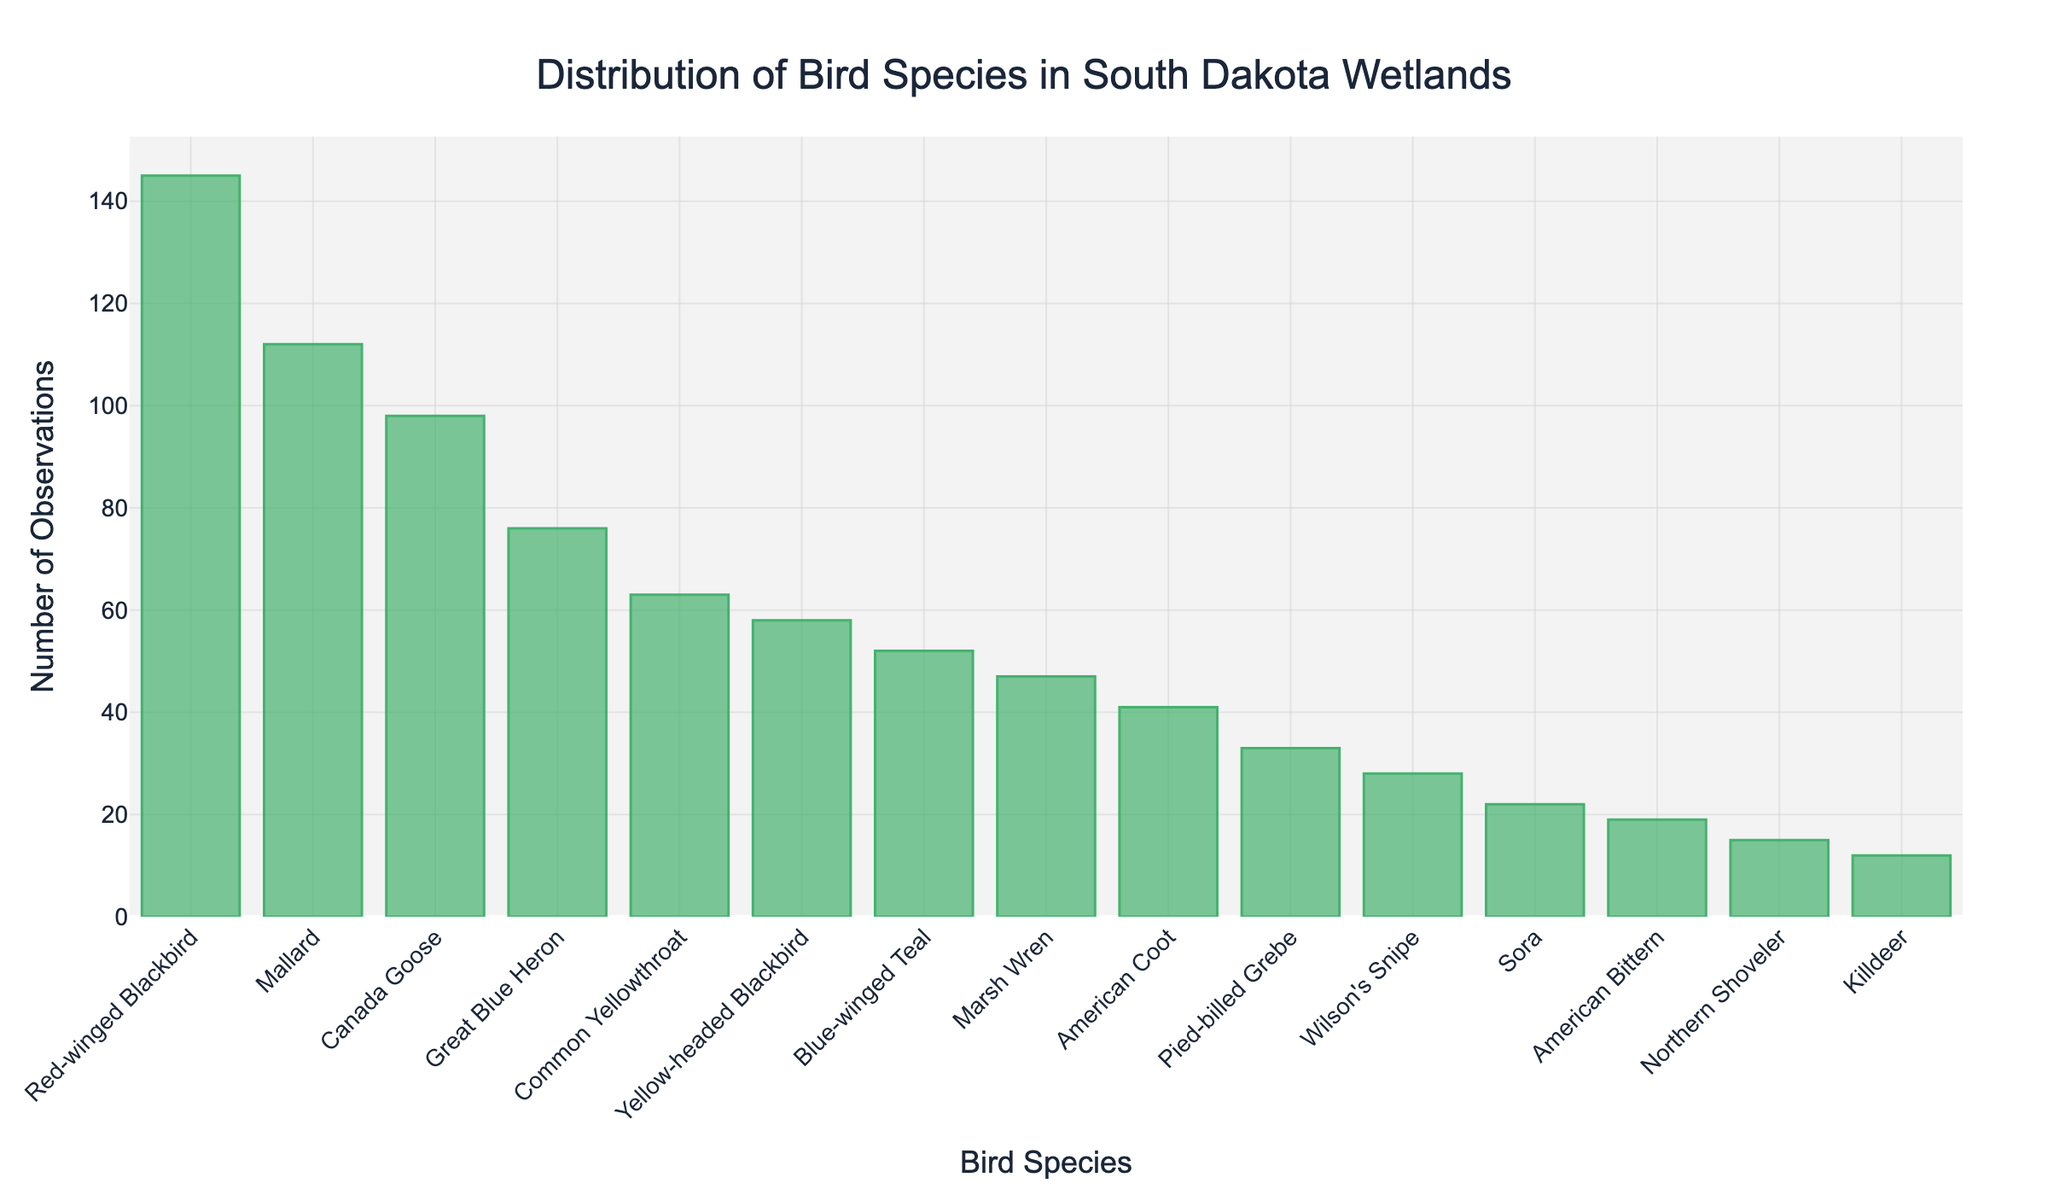What's the title of the plot? The title of the plot is located at the top and is written in a larger font size. It summarizes the main content of the plot, which in this case is related to the distribution of bird species.
Answer: Distribution of Bird Species in South Dakota Wetlands How many birds species are included in the plot? By counting the number of x-axis tick labels which represent the bird species, we can determine the total number of bird species included.
Answer: 15 Which bird species has the highest number of observations? To find the bird species with the highest number of observations, look for the tallest bar on the histogram. The label corresponding to this bar is the species with the highest count.
Answer: Red-winged Blackbird What is the total number of observations for the top three bird species combined? Summing the number of observations for the top three species: Red-winged Blackbird (145), Mallard (112), Canada Goose (98): 145 + 112 + 98.
Answer: 355 Which bird species has fewer observations: Northern Shoveler or Killdeer? Compare the lengths of the bars for Northern Shoveler and Killdeer. The shorter bar corresponds to the species with fewer observations.
Answer: Killdeer What is the number of observations for Marsh Wren? Look at the bar corresponding to Marsh Wren and read its height.
Answer: 47 How many bird species have more than 50 observations? Count the number of bars that extend above the 50 observation mark on the y-axis.
Answer: 7 What is the difference in the number of observations between Great Blue Heron and Sora? Subtract the number of observations of Sora from Great Blue Heron: 76 - 22.
Answer: 54 How many birds species have fewer than 30 observations? Count the bars that do not reach the 30 mark on the y-axis.
Answer: 5 What bird species has the closest number of observations to 50? Compare the heights of the bars to 50 and find the bird species whose bar is closest in height to the 50 mark.
Answer: Blue-winged Teal 